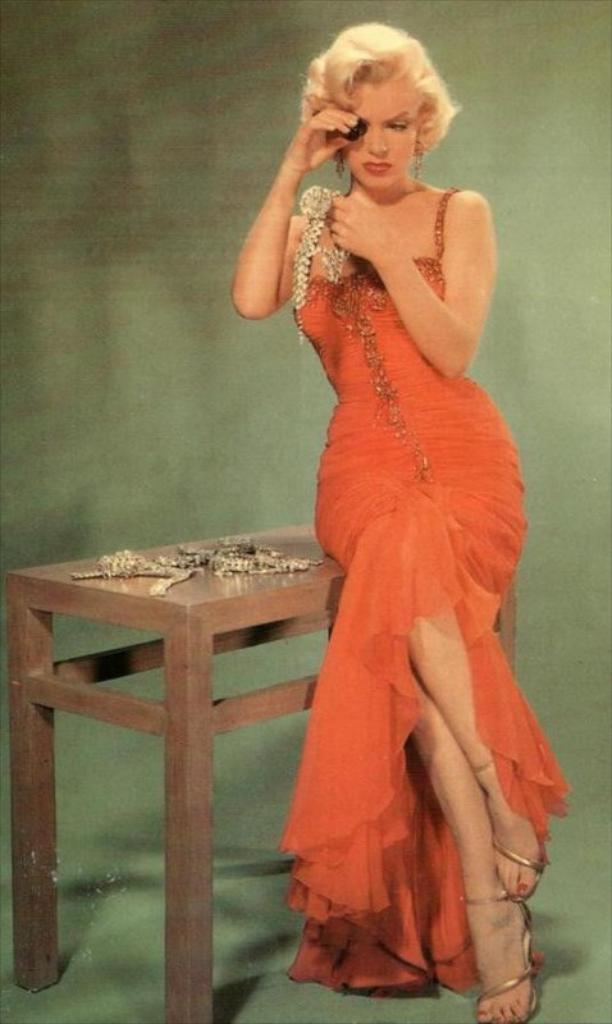Who is present in the image? There is a woman in the image. What is the woman doing in the image? The woman is standing. What object can be seen in the image besides the woman? There is a table in the image. What items are on the table in the image? There are jewelry items on the table. How does the woman maintain her silence in the image? The image does not convey any information about the woman's silence or lack thereof. --- 